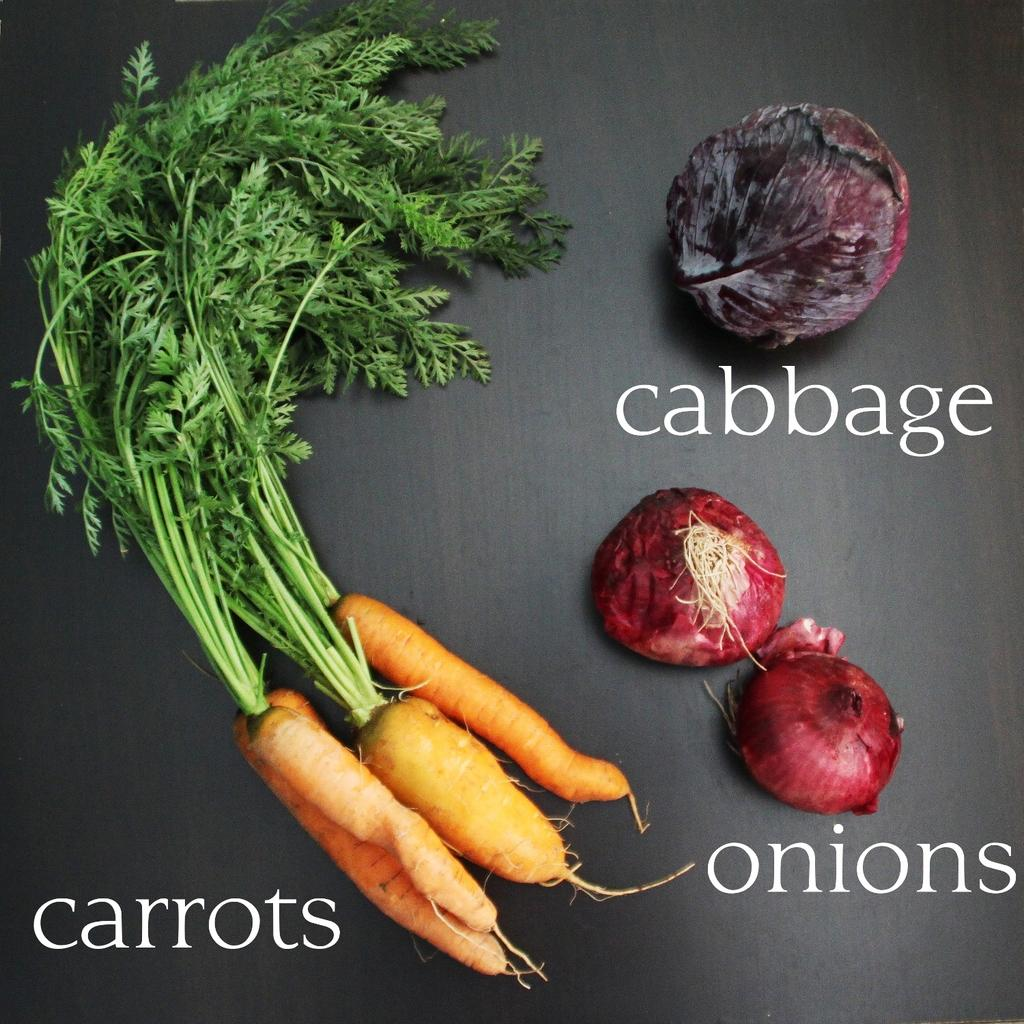What type of vegetables are present in the image? There are carrots, onions, and a beetroot in the image. Can you describe the colors of the vegetables in the image? The carrots are orange, the onions are white, and the beetroot is red. Are there any other vegetables or food items visible in the image? No, the image only shows carrots, onions, and a beetroot. What advice can be seen written on the vegetables in the image? There is no advice written on the vegetables in the image. The image only shows carrots, onions, and a beetroot. 